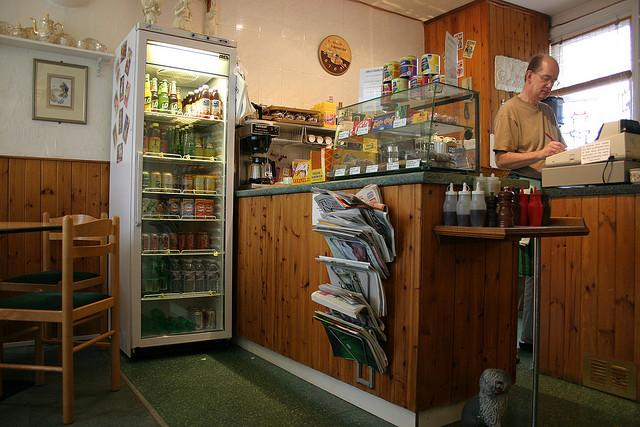What is likely sold here?

Choices:
A) video games
B) action figures
C) newspaper
D) model airplanes newspaper 